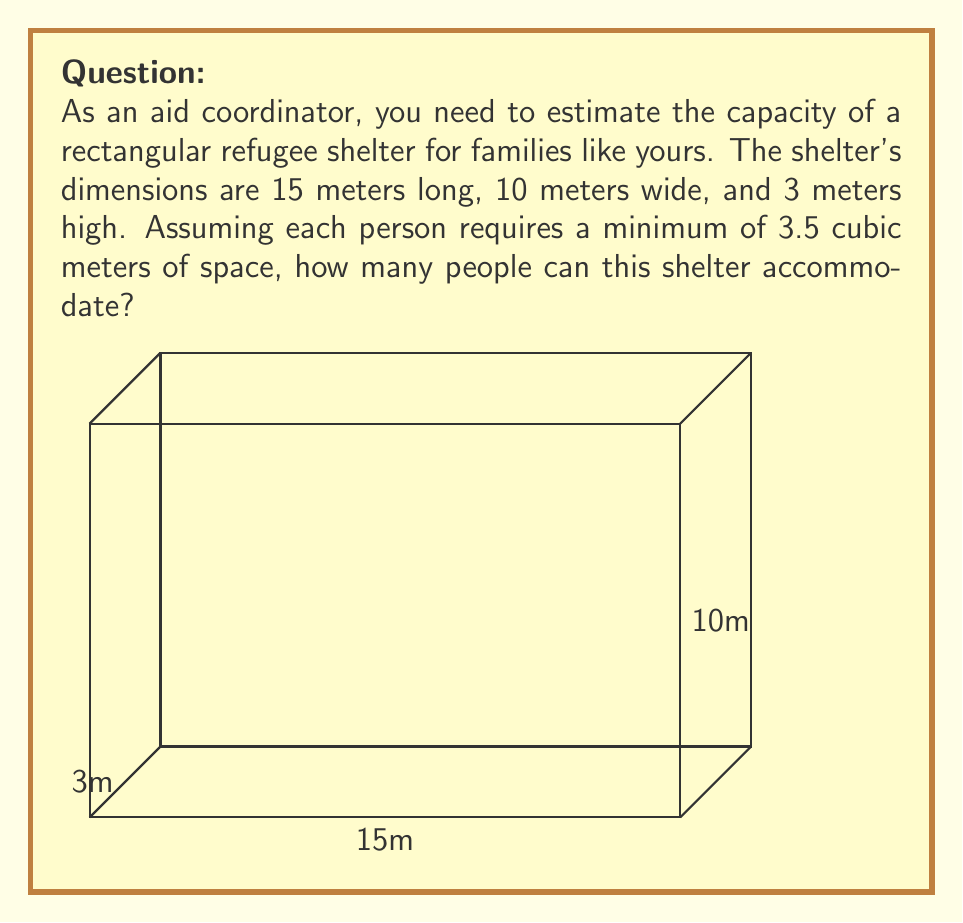Provide a solution to this math problem. To solve this problem, we'll follow these steps:

1) First, calculate the volume of the shelter:
   $$ V = length \times width \times height $$
   $$ V = 15\text{ m} \times 10\text{ m} \times 3\text{ m} = 450\text{ m}^3 $$

2) Now, we know that each person requires 3.5 cubic meters of space. To find the number of people the shelter can accommodate, we divide the total volume by the space required per person:

   $$ \text{Number of people} = \frac{\text{Total volume}}{\text{Volume per person}} $$
   $$ \text{Number of people} = \frac{450\text{ m}^3}{3.5\text{ m}^3/\text{person}} $$

3) Perform the division:
   $$ \text{Number of people} = 128.57 $$

4) Since we can't accommodate a fraction of a person, we round down to the nearest whole number:
   $$ \text{Number of people} = 128 $$

Therefore, the shelter can accommodate 128 people.
Answer: 128 people 